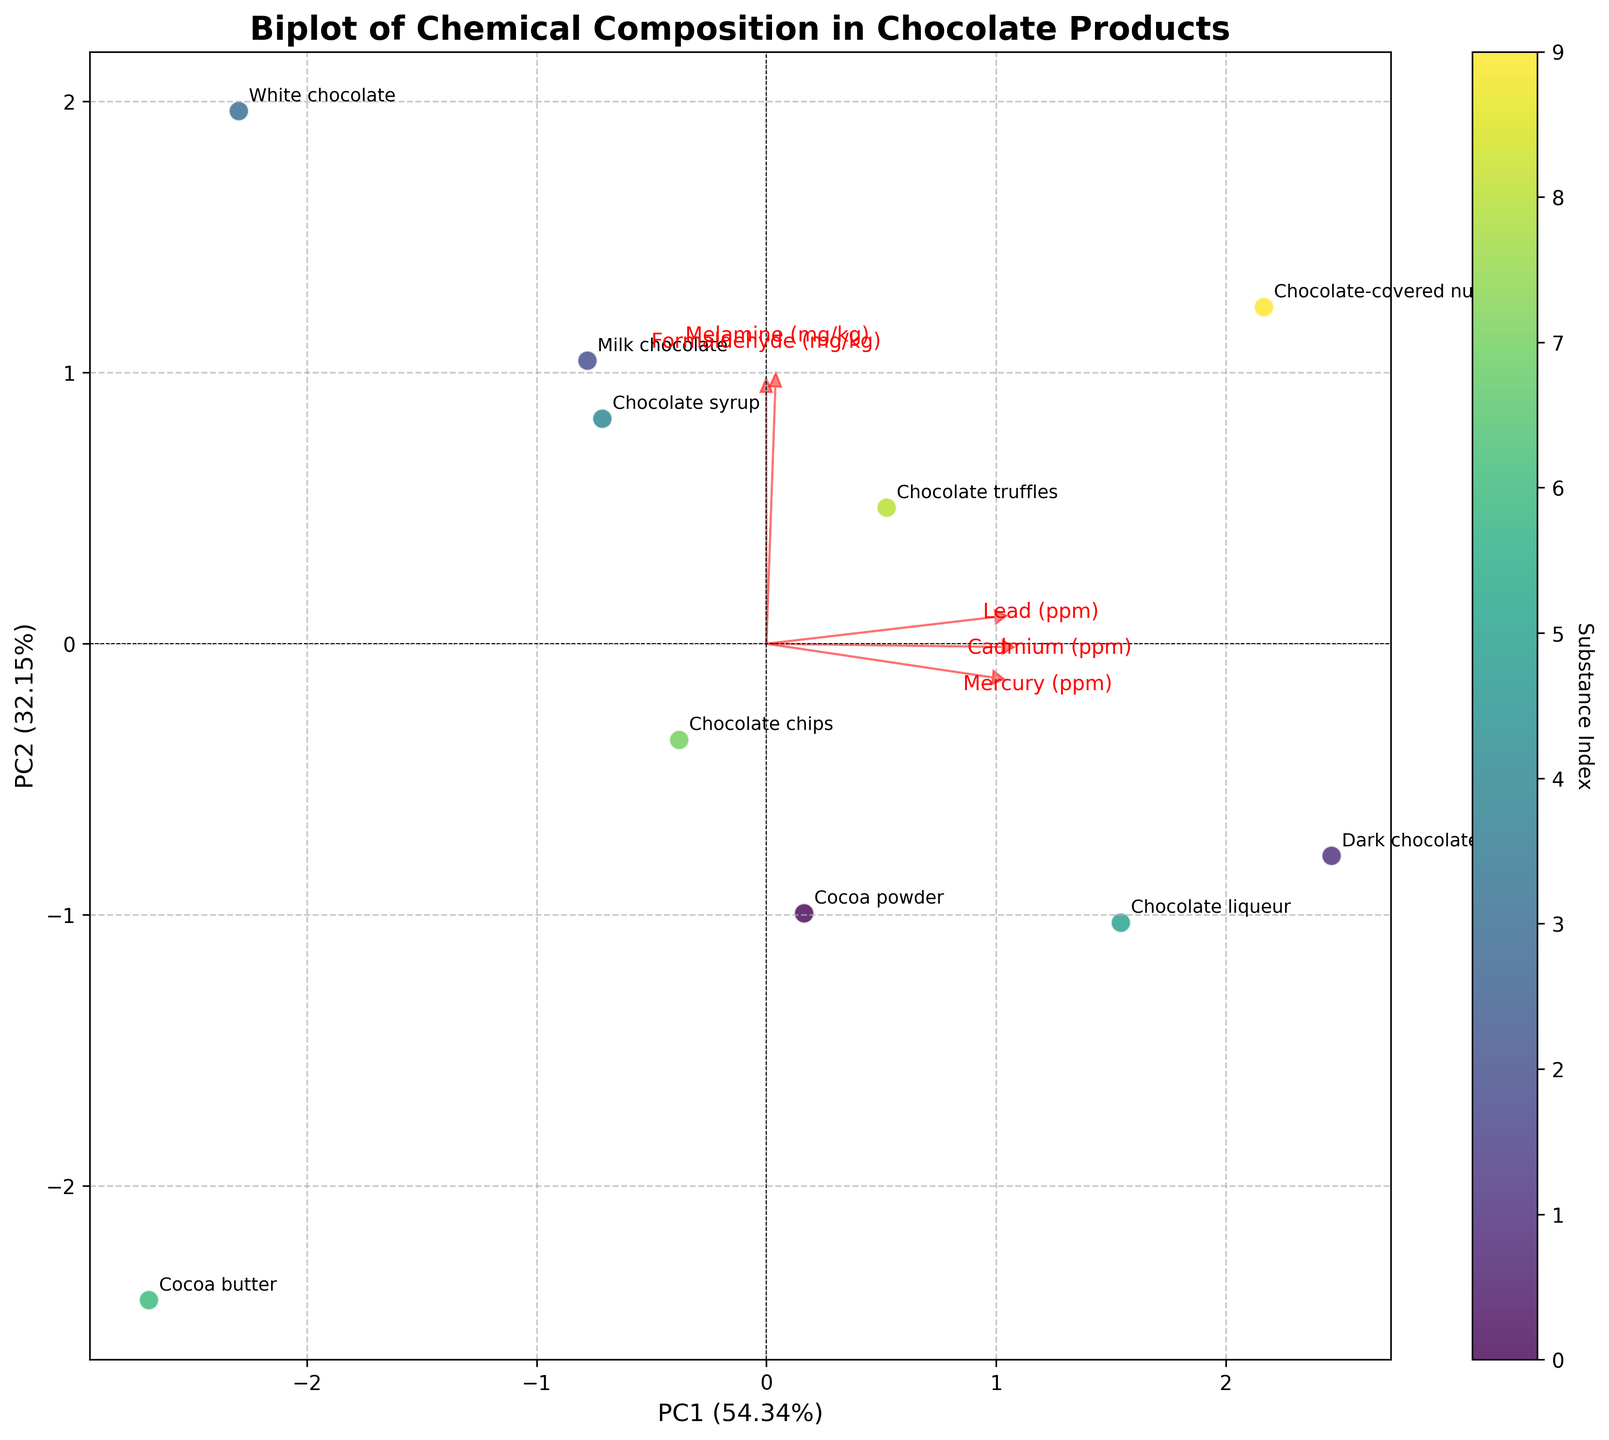How many substances are depicted in the biplot? Count the number of annotated data points labeled with substance names in the biplot.
Answer: 10 What is the title of the plot? Look at the text at the top-center of the figure which consists of the plot's title.
Answer: Biplot of Chemical Composition in Chocolate Products Which substance has the highest Formaldehyde content? Check the direction of the vector labeled "Formaldehyde" and identify which data point falls furthest in that direction.
Answer: Chocolate syrup Are any two substances located exactly at the same coordinates in the biplot? Observe the positions of annotated points and verify if any overlap completely.
Answer: No Which principal component explains a higher variance? Check the values in the axis labels for PC1 and PC2.
Answer: PC1 Which substance is furthest from the origin in the direction of the Mercury variable? Trace the direction of the "Mercury" arrow from the origin and see which point lies closest to the tip of the arrow.
Answer: Dark chocolate Can you specify the relationship between Cocoa butter and Chocolate syrup in terms of Melamine content? Examine the positions of "Cocoa butter" and "Chocolate syrup" relative to the "Melamine" vector to determine which point is further along the direction of the "Melamine" arrow.
Answer: Chocolate syrup has higher Melamine content than Cocoa butter What percentage of total variance does the first principal component (PC1) explain? Refer to the label on the x-axis which states the percentage of variance explained by PC1.
Answer: ~40% Which substance is closest to the origin of the biplot? Identify the data point or points that are nearest to the center point (0,0) of the plot.
Answer: Cocoa butter How are Chocolate chips and Chocolate truffles positioned relative to each other on PC1? Compare the x-position (first principal component) of "Chocolate chips" and "Chocolate truffles" to see which one is further to the right.
Answer: Chocolate truffles are to the right of Chocolate chips on PC1 